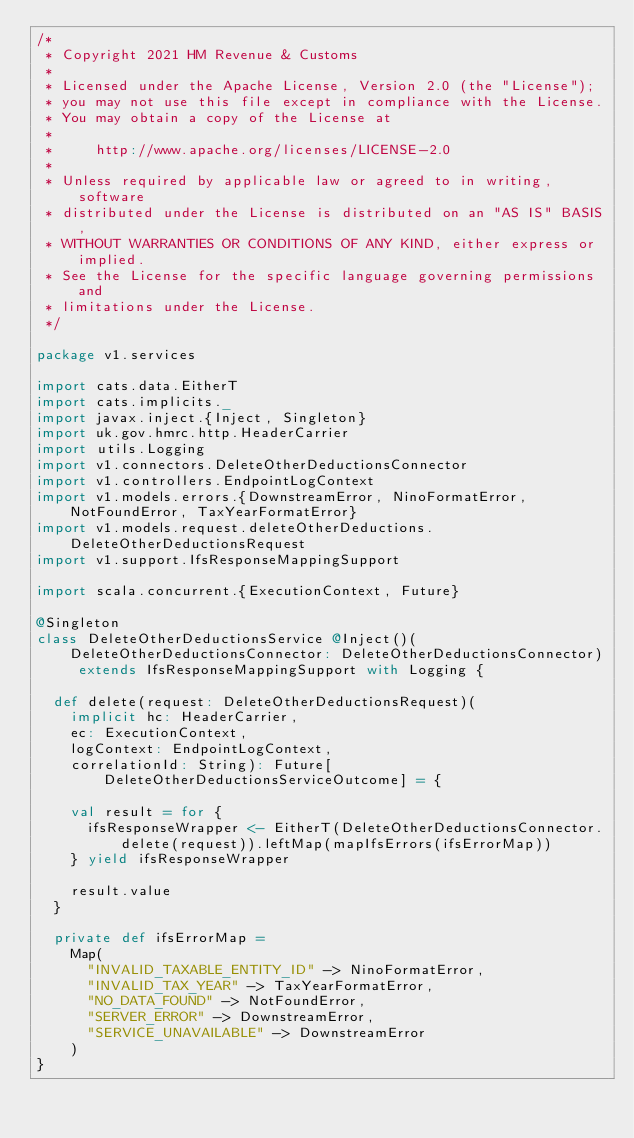Convert code to text. <code><loc_0><loc_0><loc_500><loc_500><_Scala_>/*
 * Copyright 2021 HM Revenue & Customs
 *
 * Licensed under the Apache License, Version 2.0 (the "License");
 * you may not use this file except in compliance with the License.
 * You may obtain a copy of the License at
 *
 *     http://www.apache.org/licenses/LICENSE-2.0
 *
 * Unless required by applicable law or agreed to in writing, software
 * distributed under the License is distributed on an "AS IS" BASIS,
 * WITHOUT WARRANTIES OR CONDITIONS OF ANY KIND, either express or implied.
 * See the License for the specific language governing permissions and
 * limitations under the License.
 */

package v1.services

import cats.data.EitherT
import cats.implicits._
import javax.inject.{Inject, Singleton}
import uk.gov.hmrc.http.HeaderCarrier
import utils.Logging
import v1.connectors.DeleteOtherDeductionsConnector
import v1.controllers.EndpointLogContext
import v1.models.errors.{DownstreamError, NinoFormatError, NotFoundError, TaxYearFormatError}
import v1.models.request.deleteOtherDeductions.DeleteOtherDeductionsRequest
import v1.support.IfsResponseMappingSupport

import scala.concurrent.{ExecutionContext, Future}

@Singleton
class DeleteOtherDeductionsService @Inject()(DeleteOtherDeductionsConnector: DeleteOtherDeductionsConnector) extends IfsResponseMappingSupport with Logging {

  def delete(request: DeleteOtherDeductionsRequest)(
    implicit hc: HeaderCarrier,
    ec: ExecutionContext,
    logContext: EndpointLogContext,
    correlationId: String): Future[DeleteOtherDeductionsServiceOutcome] = {

    val result = for {
      ifsResponseWrapper <- EitherT(DeleteOtherDeductionsConnector.delete(request)).leftMap(mapIfsErrors(ifsErrorMap))
    } yield ifsResponseWrapper

    result.value
  }

  private def ifsErrorMap =
    Map(
      "INVALID_TAXABLE_ENTITY_ID" -> NinoFormatError,
      "INVALID_TAX_YEAR" -> TaxYearFormatError,
      "NO_DATA_FOUND" -> NotFoundError,
      "SERVER_ERROR" -> DownstreamError,
      "SERVICE_UNAVAILABLE" -> DownstreamError
    )
}
</code> 